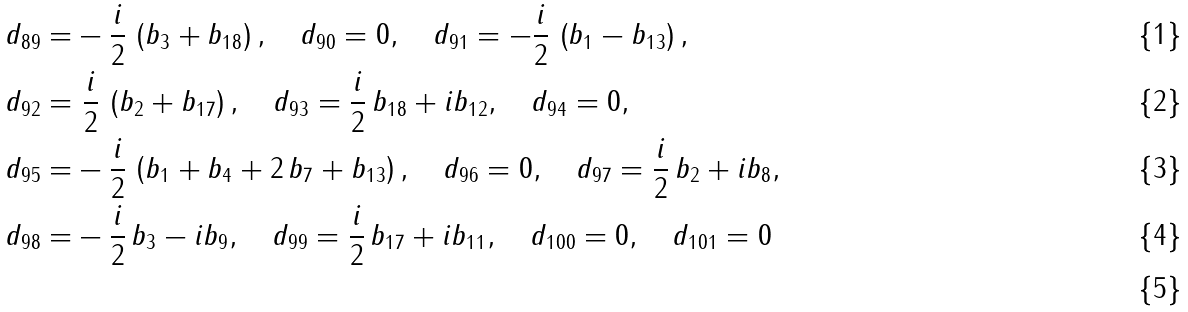<formula> <loc_0><loc_0><loc_500><loc_500>d _ { 8 9 } = & - \frac { i } { 2 } \, \left ( b _ { 3 } + b _ { 1 8 } \right ) , \quad d _ { 9 0 } = 0 , \quad d _ { 9 1 } = - \frac { i } { 2 } \, \left ( b _ { 1 } - b _ { 1 3 } \right ) , \\ d _ { 9 2 } = & \ \frac { i } { 2 } \, \left ( b _ { 2 } + b _ { 1 7 } \right ) , \quad d _ { 9 3 } = \frac { i } { 2 } \, b _ { 1 8 } + i b _ { 1 2 } , \quad d _ { 9 4 } = 0 , \\ d _ { 9 5 } = & - \frac { i } { 2 } \, \left ( b _ { 1 } + b _ { 4 } + 2 \, b _ { 7 } + b _ { 1 3 } \right ) , \quad d _ { 9 6 } = 0 , \quad d _ { 9 7 } = \frac { i } { 2 } \, b _ { 2 } + i b _ { 8 } , \\ d _ { 9 8 } = & - \frac { i } { 2 } \, b _ { 3 } - i b _ { 9 } , \quad d _ { 9 9 } = \frac { i } { 2 } \, b _ { 1 7 } + i b _ { 1 1 } , \quad d _ { 1 0 0 } = 0 , \quad d _ { 1 0 1 } = 0 \\</formula> 